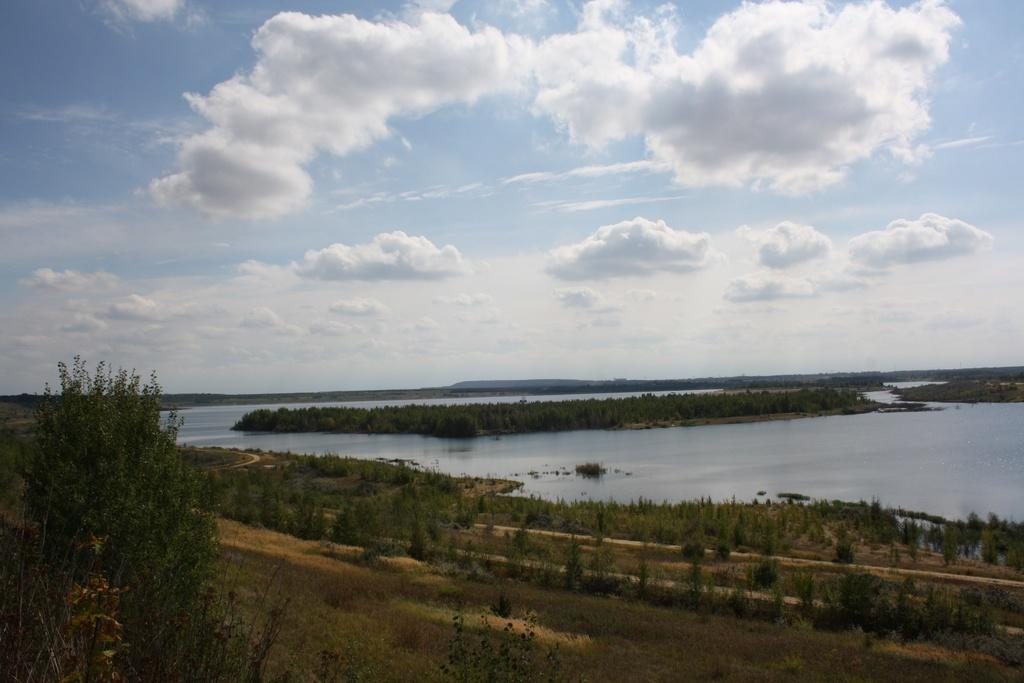What type of vegetation can be seen in the image? There is a group of trees in the image. What natural element is visible in the image besides the trees? There is water visible in the image. What can be seen in the distance in the image? There are mountains in the background of the image. What else is visible in the background of the image? The sky is visible in the background of the image. How many girls are holding vases in the image? There are no girls or vases present in the image. 